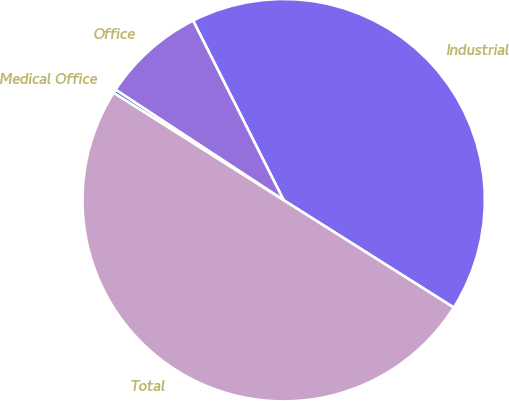Convert chart. <chart><loc_0><loc_0><loc_500><loc_500><pie_chart><fcel>Industrial<fcel>Office<fcel>Medical Office<fcel>Total<nl><fcel>41.39%<fcel>8.31%<fcel>0.29%<fcel>50.0%<nl></chart> 